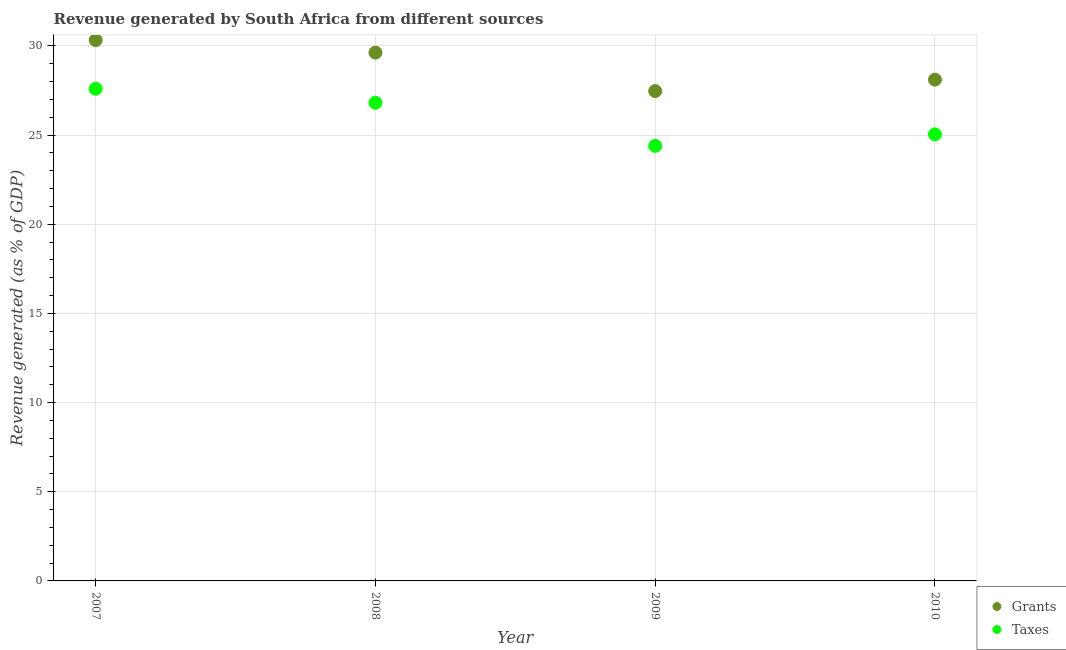What is the revenue generated by taxes in 2007?
Your answer should be compact. 27.6. Across all years, what is the maximum revenue generated by grants?
Your answer should be compact. 30.32. Across all years, what is the minimum revenue generated by taxes?
Give a very brief answer. 24.4. In which year was the revenue generated by grants maximum?
Your answer should be compact. 2007. What is the total revenue generated by grants in the graph?
Make the answer very short. 115.52. What is the difference between the revenue generated by grants in 2009 and that in 2010?
Make the answer very short. -0.64. What is the difference between the revenue generated by taxes in 2010 and the revenue generated by grants in 2009?
Ensure brevity in your answer.  -2.43. What is the average revenue generated by taxes per year?
Keep it short and to the point. 25.96. In the year 2007, what is the difference between the revenue generated by grants and revenue generated by taxes?
Ensure brevity in your answer.  2.73. What is the ratio of the revenue generated by grants in 2007 to that in 2009?
Provide a succinct answer. 1.1. What is the difference between the highest and the second highest revenue generated by grants?
Your response must be concise. 0.7. What is the difference between the highest and the lowest revenue generated by grants?
Offer a very short reply. 2.85. In how many years, is the revenue generated by grants greater than the average revenue generated by grants taken over all years?
Provide a succinct answer. 2. Is the sum of the revenue generated by grants in 2009 and 2010 greater than the maximum revenue generated by taxes across all years?
Offer a terse response. Yes. Does the revenue generated by taxes monotonically increase over the years?
Provide a short and direct response. No. Is the revenue generated by taxes strictly less than the revenue generated by grants over the years?
Make the answer very short. Yes. What is the difference between two consecutive major ticks on the Y-axis?
Your answer should be compact. 5. How many legend labels are there?
Offer a terse response. 2. How are the legend labels stacked?
Provide a short and direct response. Vertical. What is the title of the graph?
Ensure brevity in your answer.  Revenue generated by South Africa from different sources. What is the label or title of the Y-axis?
Your answer should be very brief. Revenue generated (as % of GDP). What is the Revenue generated (as % of GDP) of Grants in 2007?
Make the answer very short. 30.32. What is the Revenue generated (as % of GDP) in Taxes in 2007?
Make the answer very short. 27.6. What is the Revenue generated (as % of GDP) in Grants in 2008?
Offer a terse response. 29.62. What is the Revenue generated (as % of GDP) in Taxes in 2008?
Your answer should be compact. 26.81. What is the Revenue generated (as % of GDP) of Grants in 2009?
Offer a terse response. 27.47. What is the Revenue generated (as % of GDP) in Taxes in 2009?
Provide a succinct answer. 24.4. What is the Revenue generated (as % of GDP) in Grants in 2010?
Your answer should be very brief. 28.11. What is the Revenue generated (as % of GDP) in Taxes in 2010?
Your answer should be compact. 25.04. Across all years, what is the maximum Revenue generated (as % of GDP) of Grants?
Offer a terse response. 30.32. Across all years, what is the maximum Revenue generated (as % of GDP) in Taxes?
Keep it short and to the point. 27.6. Across all years, what is the minimum Revenue generated (as % of GDP) of Grants?
Offer a terse response. 27.47. Across all years, what is the minimum Revenue generated (as % of GDP) of Taxes?
Your answer should be compact. 24.4. What is the total Revenue generated (as % of GDP) of Grants in the graph?
Ensure brevity in your answer.  115.52. What is the total Revenue generated (as % of GDP) of Taxes in the graph?
Offer a very short reply. 103.85. What is the difference between the Revenue generated (as % of GDP) in Taxes in 2007 and that in 2008?
Your response must be concise. 0.78. What is the difference between the Revenue generated (as % of GDP) of Grants in 2007 and that in 2009?
Your answer should be compact. 2.85. What is the difference between the Revenue generated (as % of GDP) of Taxes in 2007 and that in 2009?
Make the answer very short. 3.2. What is the difference between the Revenue generated (as % of GDP) in Grants in 2007 and that in 2010?
Keep it short and to the point. 2.21. What is the difference between the Revenue generated (as % of GDP) of Taxes in 2007 and that in 2010?
Offer a terse response. 2.55. What is the difference between the Revenue generated (as % of GDP) in Grants in 2008 and that in 2009?
Offer a terse response. 2.15. What is the difference between the Revenue generated (as % of GDP) in Taxes in 2008 and that in 2009?
Your response must be concise. 2.42. What is the difference between the Revenue generated (as % of GDP) of Grants in 2008 and that in 2010?
Give a very brief answer. 1.51. What is the difference between the Revenue generated (as % of GDP) of Taxes in 2008 and that in 2010?
Offer a terse response. 1.77. What is the difference between the Revenue generated (as % of GDP) in Grants in 2009 and that in 2010?
Keep it short and to the point. -0.64. What is the difference between the Revenue generated (as % of GDP) in Taxes in 2009 and that in 2010?
Provide a succinct answer. -0.64. What is the difference between the Revenue generated (as % of GDP) of Grants in 2007 and the Revenue generated (as % of GDP) of Taxes in 2008?
Make the answer very short. 3.51. What is the difference between the Revenue generated (as % of GDP) in Grants in 2007 and the Revenue generated (as % of GDP) in Taxes in 2009?
Your response must be concise. 5.93. What is the difference between the Revenue generated (as % of GDP) in Grants in 2007 and the Revenue generated (as % of GDP) in Taxes in 2010?
Offer a very short reply. 5.28. What is the difference between the Revenue generated (as % of GDP) in Grants in 2008 and the Revenue generated (as % of GDP) in Taxes in 2009?
Provide a short and direct response. 5.23. What is the difference between the Revenue generated (as % of GDP) of Grants in 2008 and the Revenue generated (as % of GDP) of Taxes in 2010?
Provide a succinct answer. 4.58. What is the difference between the Revenue generated (as % of GDP) in Grants in 2009 and the Revenue generated (as % of GDP) in Taxes in 2010?
Make the answer very short. 2.43. What is the average Revenue generated (as % of GDP) in Grants per year?
Your answer should be compact. 28.88. What is the average Revenue generated (as % of GDP) of Taxes per year?
Your answer should be compact. 25.96. In the year 2007, what is the difference between the Revenue generated (as % of GDP) in Grants and Revenue generated (as % of GDP) in Taxes?
Ensure brevity in your answer.  2.73. In the year 2008, what is the difference between the Revenue generated (as % of GDP) in Grants and Revenue generated (as % of GDP) in Taxes?
Offer a very short reply. 2.81. In the year 2009, what is the difference between the Revenue generated (as % of GDP) in Grants and Revenue generated (as % of GDP) in Taxes?
Give a very brief answer. 3.07. In the year 2010, what is the difference between the Revenue generated (as % of GDP) in Grants and Revenue generated (as % of GDP) in Taxes?
Offer a very short reply. 3.07. What is the ratio of the Revenue generated (as % of GDP) in Grants in 2007 to that in 2008?
Provide a succinct answer. 1.02. What is the ratio of the Revenue generated (as % of GDP) of Taxes in 2007 to that in 2008?
Ensure brevity in your answer.  1.03. What is the ratio of the Revenue generated (as % of GDP) in Grants in 2007 to that in 2009?
Keep it short and to the point. 1.1. What is the ratio of the Revenue generated (as % of GDP) in Taxes in 2007 to that in 2009?
Provide a succinct answer. 1.13. What is the ratio of the Revenue generated (as % of GDP) in Grants in 2007 to that in 2010?
Your answer should be compact. 1.08. What is the ratio of the Revenue generated (as % of GDP) in Taxes in 2007 to that in 2010?
Provide a short and direct response. 1.1. What is the ratio of the Revenue generated (as % of GDP) of Grants in 2008 to that in 2009?
Provide a succinct answer. 1.08. What is the ratio of the Revenue generated (as % of GDP) of Taxes in 2008 to that in 2009?
Offer a very short reply. 1.1. What is the ratio of the Revenue generated (as % of GDP) of Grants in 2008 to that in 2010?
Your response must be concise. 1.05. What is the ratio of the Revenue generated (as % of GDP) in Taxes in 2008 to that in 2010?
Provide a succinct answer. 1.07. What is the ratio of the Revenue generated (as % of GDP) of Grants in 2009 to that in 2010?
Provide a succinct answer. 0.98. What is the ratio of the Revenue generated (as % of GDP) of Taxes in 2009 to that in 2010?
Your response must be concise. 0.97. What is the difference between the highest and the second highest Revenue generated (as % of GDP) in Taxes?
Ensure brevity in your answer.  0.78. What is the difference between the highest and the lowest Revenue generated (as % of GDP) of Grants?
Give a very brief answer. 2.85. What is the difference between the highest and the lowest Revenue generated (as % of GDP) of Taxes?
Keep it short and to the point. 3.2. 